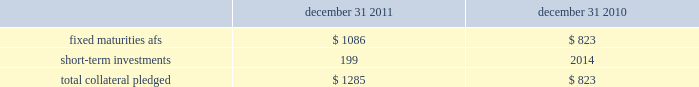The hartford financial services group , inc .
Notes to consolidated financial statements ( continued ) 5 .
Investments and derivative instruments ( continued ) collateral arrangements the company enters into various collateral arrangements in connection with its derivative instruments , which require both the pledging and accepting of collateral .
As of december 31 , 2011 and 2010 , collateral pledged having a fair value of $ 1.1 billion and $ 790 , respectively , was included in fixed maturities , afs , in the consolidated balance sheets .
From time to time , the company enters into secured borrowing arrangements as a means to increase net investment income .
The company received cash collateral of $ 33 as of december 31 , 2011 and 2010 .
The table presents the classification and carrying amount of loaned securities and derivative instruments collateral pledged. .
As of december 31 , 2011 and 2010 , the company had accepted collateral with a fair value of $ 2.6 billion and $ 1.5 billion , respectively , of which $ 2.0 billion and $ 1.1 billion , respectively , was cash collateral which was invested and recorded in the consolidated balance sheets in fixed maturities and short-term investments with corresponding amounts recorded in other assets and other liabilities .
The company is only permitted by contract to sell or repledge the noncash collateral in the event of a default by the counterparty .
As of december 31 , 2011 and 2010 , noncash collateral accepted was held in separate custodial accounts and was not included in the company 2019s consolidated balance sheets .
Securities on deposit with states the company is required by law to deposit securities with government agencies in states where it conducts business .
As of december 31 , 2011 and 2010 , the fair value of securities on deposit was approximately $ 1.6 billion and $ 1.4 billion , respectively. .
What is the change in fair value of securities on deposits from 2010 to 2011 , ( in billions ) ? 
Computations: (1.6 - 1.4)
Answer: 0.2. 